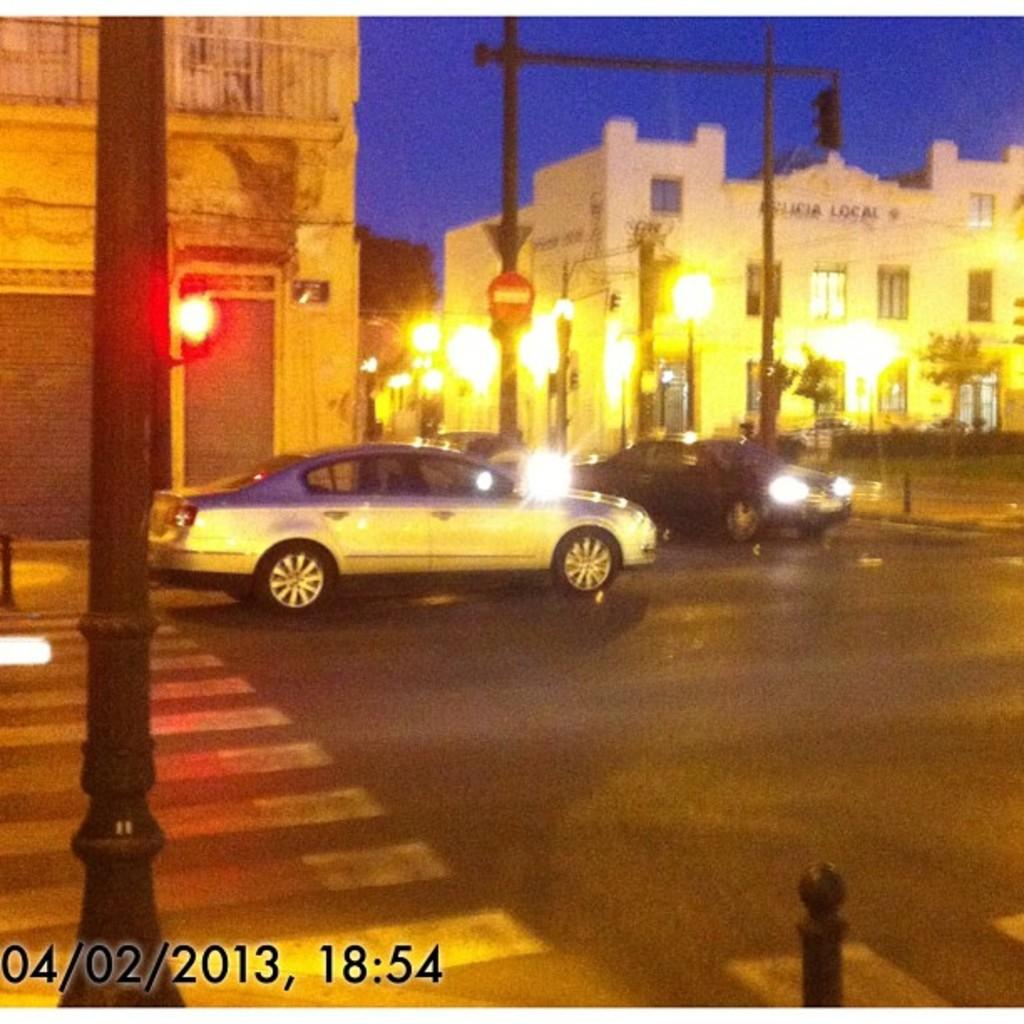<image>
Write a terse but informative summary of the picture. A photo that was taken on April 2 of 2013. 